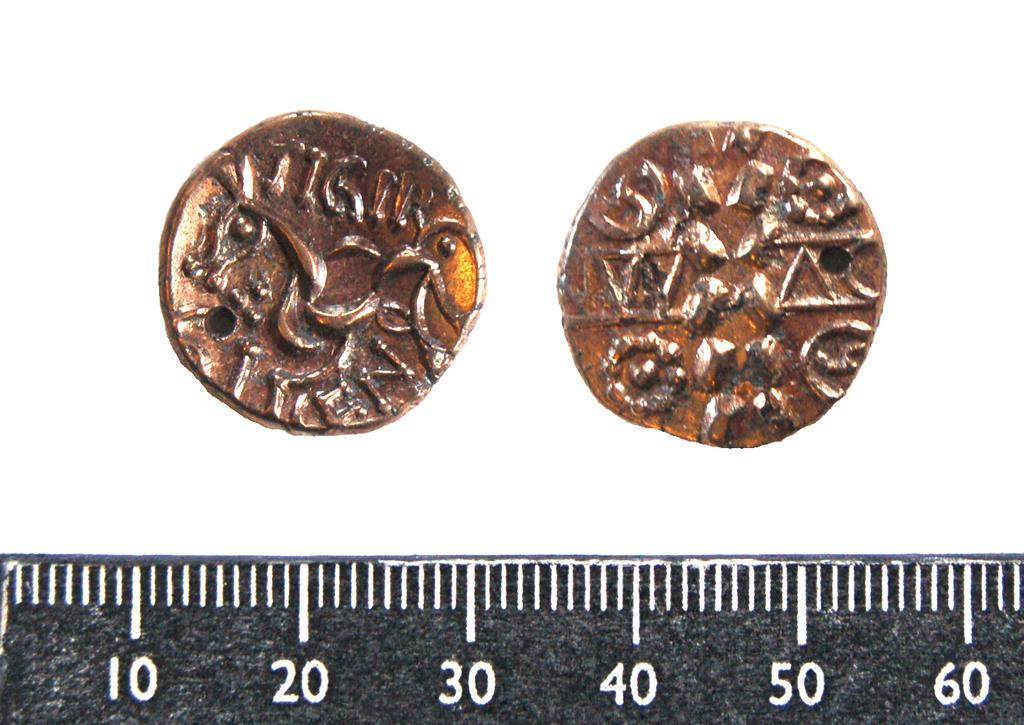What is located at the bottom of the image? There is a measurement scale at the bottom of the image. What can be seen in the image besides the measurement scale? There are coins visible in the image. What type of organization is depicted in the image? There is no organization depicted in the image; it only contains a measurement scale and coins. 